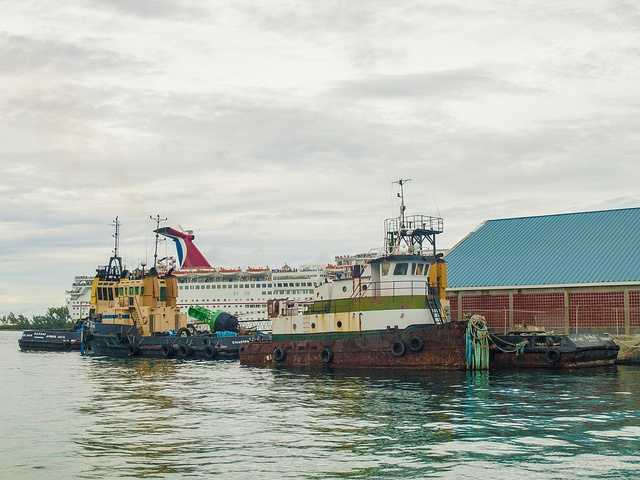Describe the objects in this image and their specific colors. I can see boat in lightgray, black, darkgray, maroon, and gray tones, boat in lightgray, black, tan, gray, and blue tones, and boat in lightgray, darkgray, and gray tones in this image. 